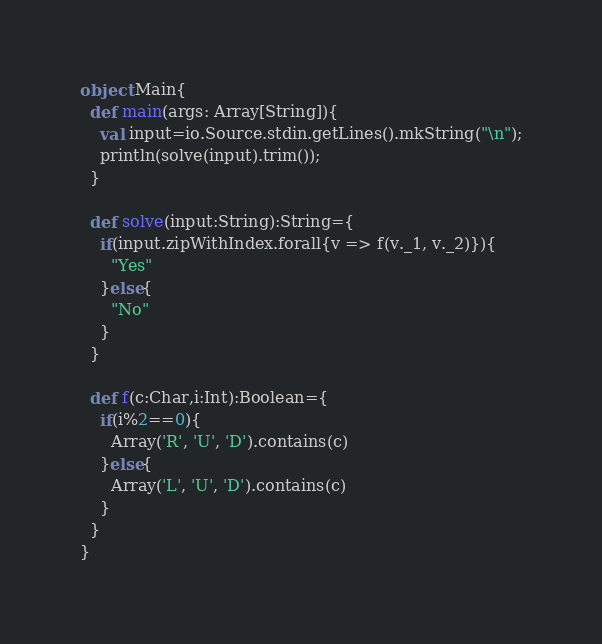<code> <loc_0><loc_0><loc_500><loc_500><_Scala_>object Main{
  def main(args: Array[String]){
    val input=io.Source.stdin.getLines().mkString("\n");
    println(solve(input).trim());
  }

  def solve(input:String):String={
    if(input.zipWithIndex.forall{v => f(v._1, v._2)}){
      "Yes"
    }else{
      "No"
    }
  }

  def f(c:Char,i:Int):Boolean={
    if(i%2==0){
      Array('R', 'U', 'D').contains(c)
    }else{
      Array('L', 'U', 'D').contains(c)
    }
  }
}
</code> 